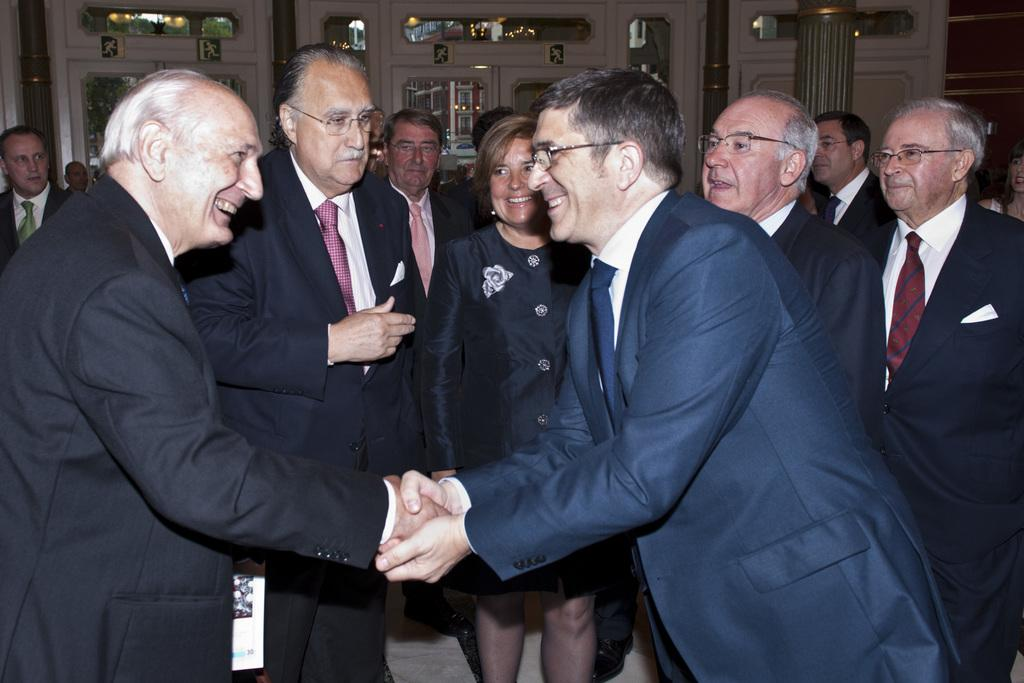How many people are smiling in the image? There are two persons standing and smiling in the image. What are the two persons doing in the image? The two persons are shaking hands in the image. Can you describe the group of people in the image? There is a group of people standing in the image. What else can be seen in the image besides the people? There are boards and other objects visible in the image. What type of salt can be seen on the wing in the image? There is no salt or wing present in the image. 